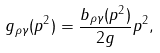Convert formula to latex. <formula><loc_0><loc_0><loc_500><loc_500>g _ { \rho \gamma } ( p ^ { 2 } ) = \frac { b _ { \rho \gamma } ( p ^ { 2 } ) } { 2 g } p ^ { 2 } ,</formula> 